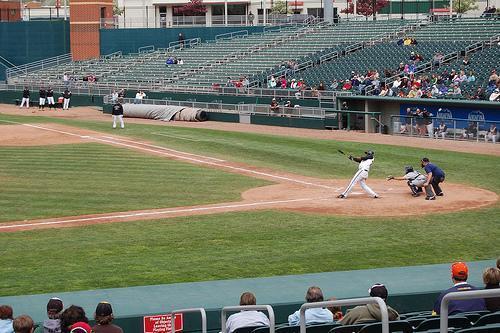How many players in the dugout?
Give a very brief answer. 6. 